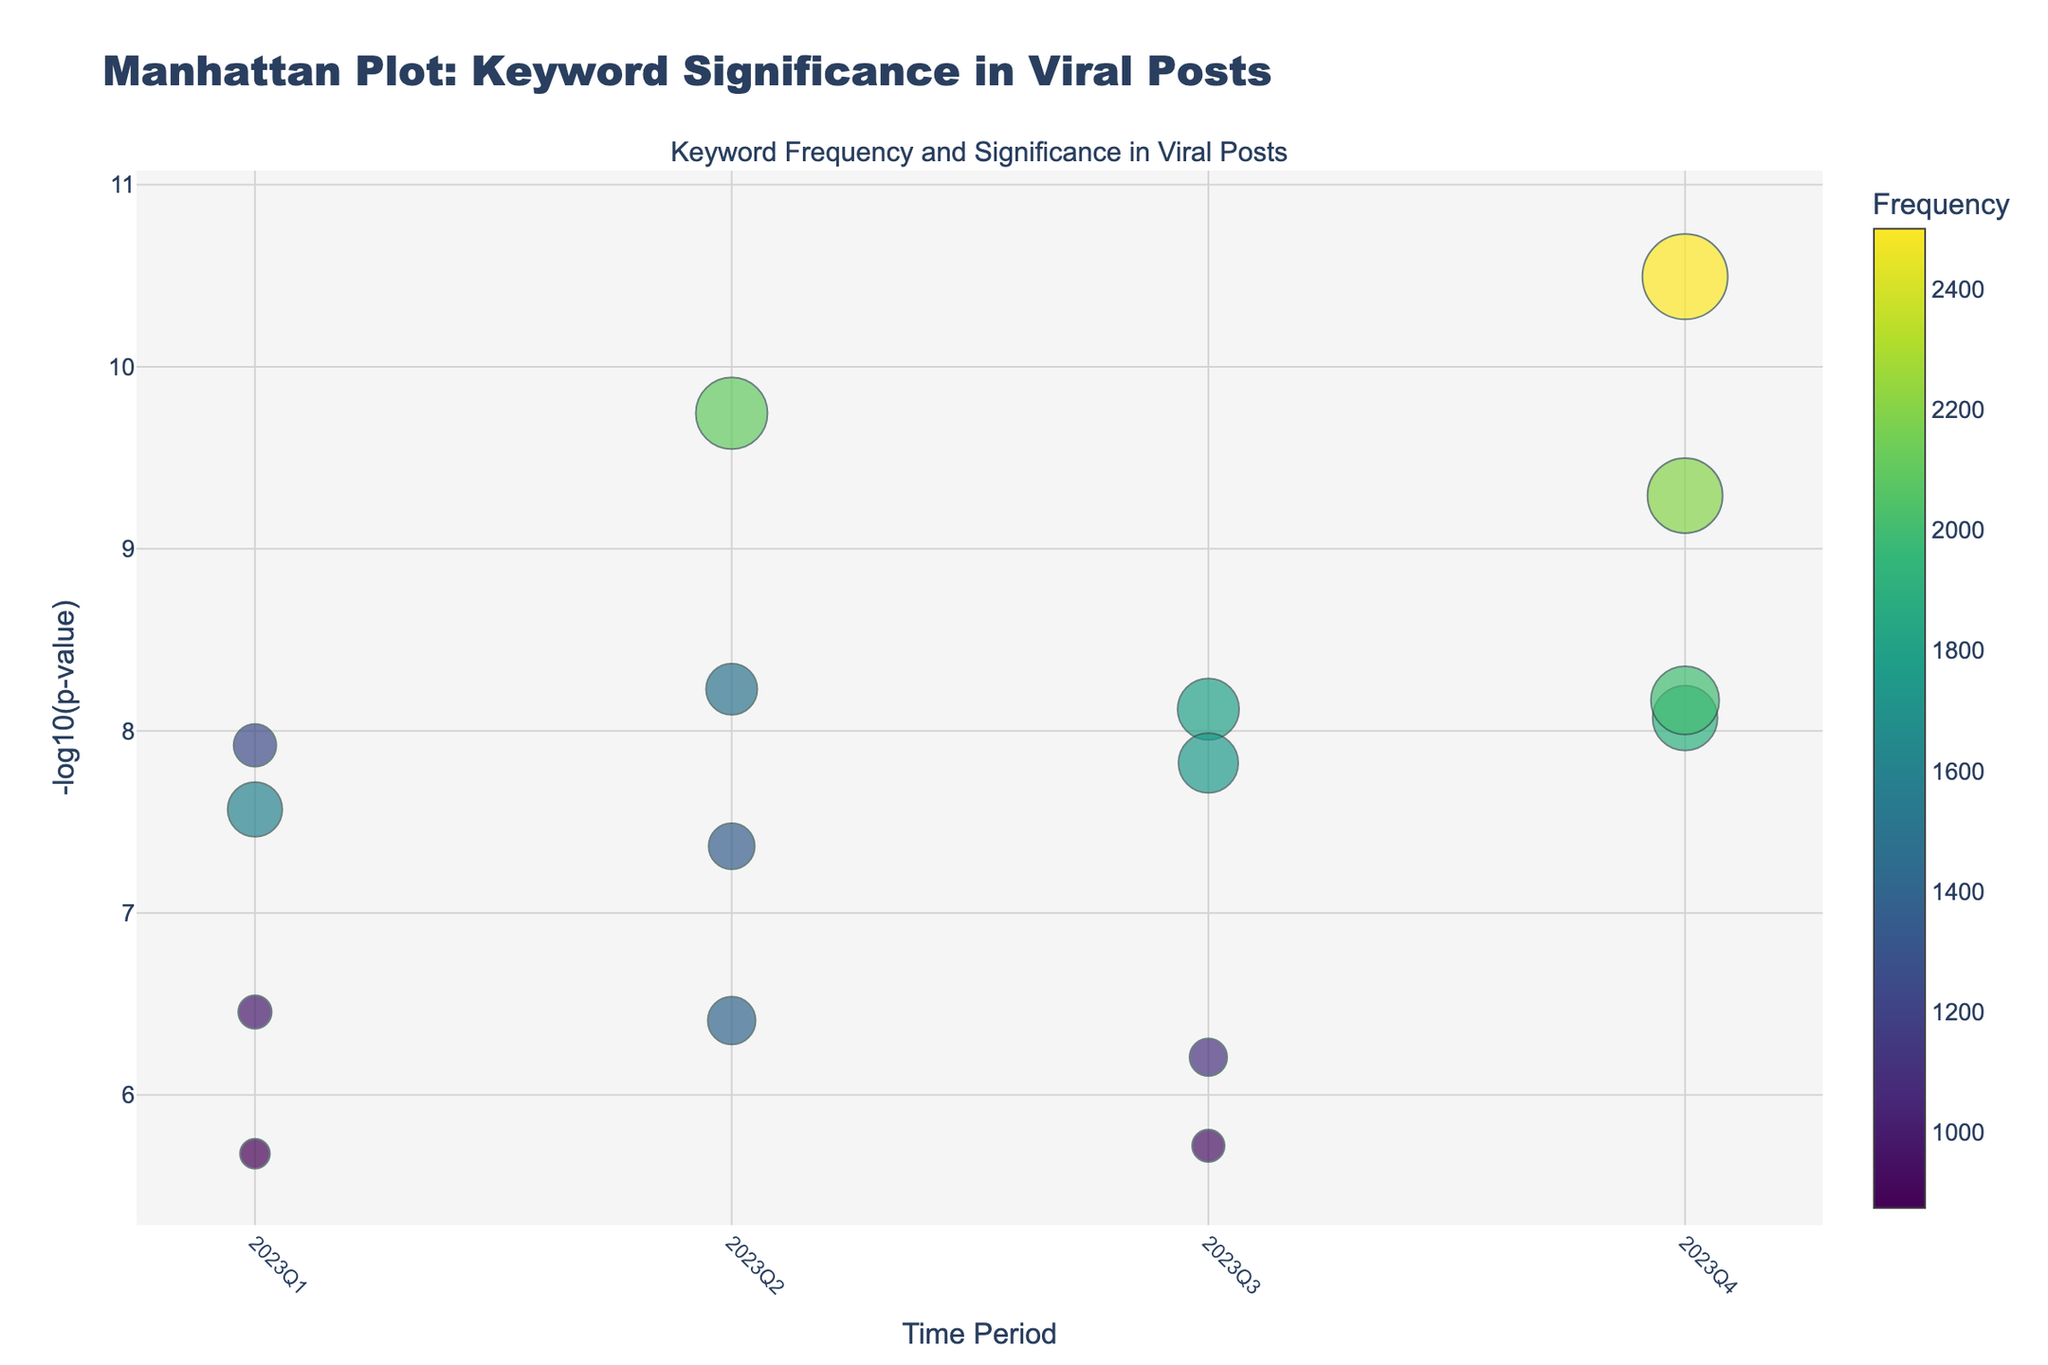What is the title of the figure? The title of the figure is found at the very top of the plot and often provides a summary of the content being displayed.
Answer: Manhattan Plot: Keyword Significance in Viral Posts Which time period contains keywords with the highest frequencies? To determine this, inspect the colors of each keyword across the time periods. The time period with the darkest markers generally represents the highest frequencies.
Answer: 2023Q4 What does the x-axis represent? The x-axis displays different time periods throughout the year 2023. The categories shown are '2023Q1', '2023Q2', '2023Q3', and '2023Q4'.
Answer: Time Period Which keyword has the smallest p-value? In a Manhattan plot, smaller p-values correspond to higher -log10(p-value) values. Therefore, the keyword with the highest position on the y-axis has the smallest p-value.
Answer: #BlackFriday How many total keywords are represented in the plot? Count the total number of distinct markers (each representing a keyword) shown in the figure.
Answer: 16 Which quarter exhibits the highest statistical significance for the keywords overall? To find this, examine the heights of the markers (representing -log10(p-value)) for each time period. The quarter with the most markers closer to the top indicates higher overall significance.
Answer: 2023Q4 What is the relationship between frequency size and marker size? The size of the markers is determined by the frequency of the keywords. Larger frequencies result in larger marker sizes.
Answer: Larger frequency, larger marker size Which keyword in Q3 has the highest frequency and what is its -log10(p-value)? In Q3, inspect the size and color of the markers. The keyword with the largest, darkest marker will have the highest frequency.
Answer: #BackToSchool, about 8.08 Compare #SummerVibes and #BlackFriday in terms of frequency and significance. Which is higher in each? Observe the size and y-position of the markers for both #SummerVibes and #BlackFriday. Compare their frequencies (size) and p-values (y-position).
Answer: #BlackFriday has higher frequency and significance What can be inferred about the keyword trends in viral posts over 2023? Look at the distribution and significance of keywords across the different time periods. Summarize the overall trends observed.
Answer: Keywords are most significant in Q4, with many showing high relevance 